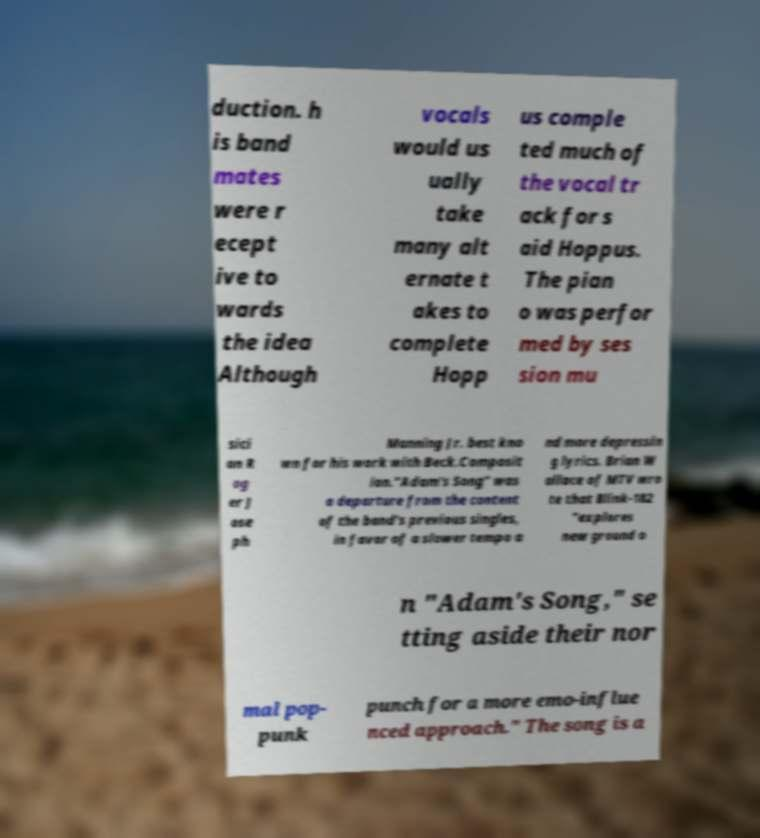I need the written content from this picture converted into text. Can you do that? duction. h is band mates were r ecept ive to wards the idea Although vocals would us ually take many alt ernate t akes to complete Hopp us comple ted much of the vocal tr ack for s aid Hoppus. The pian o was perfor med by ses sion mu sici an R og er J ose ph Manning Jr. best kno wn for his work with Beck.Composit ion."Adam's Song" was a departure from the content of the band's previous singles, in favor of a slower tempo a nd more depressin g lyrics. Brian W allace of MTV wro te that Blink-182 "explores new ground o n "Adam's Song," se tting aside their nor mal pop- punk punch for a more emo-influe nced approach." The song is a 